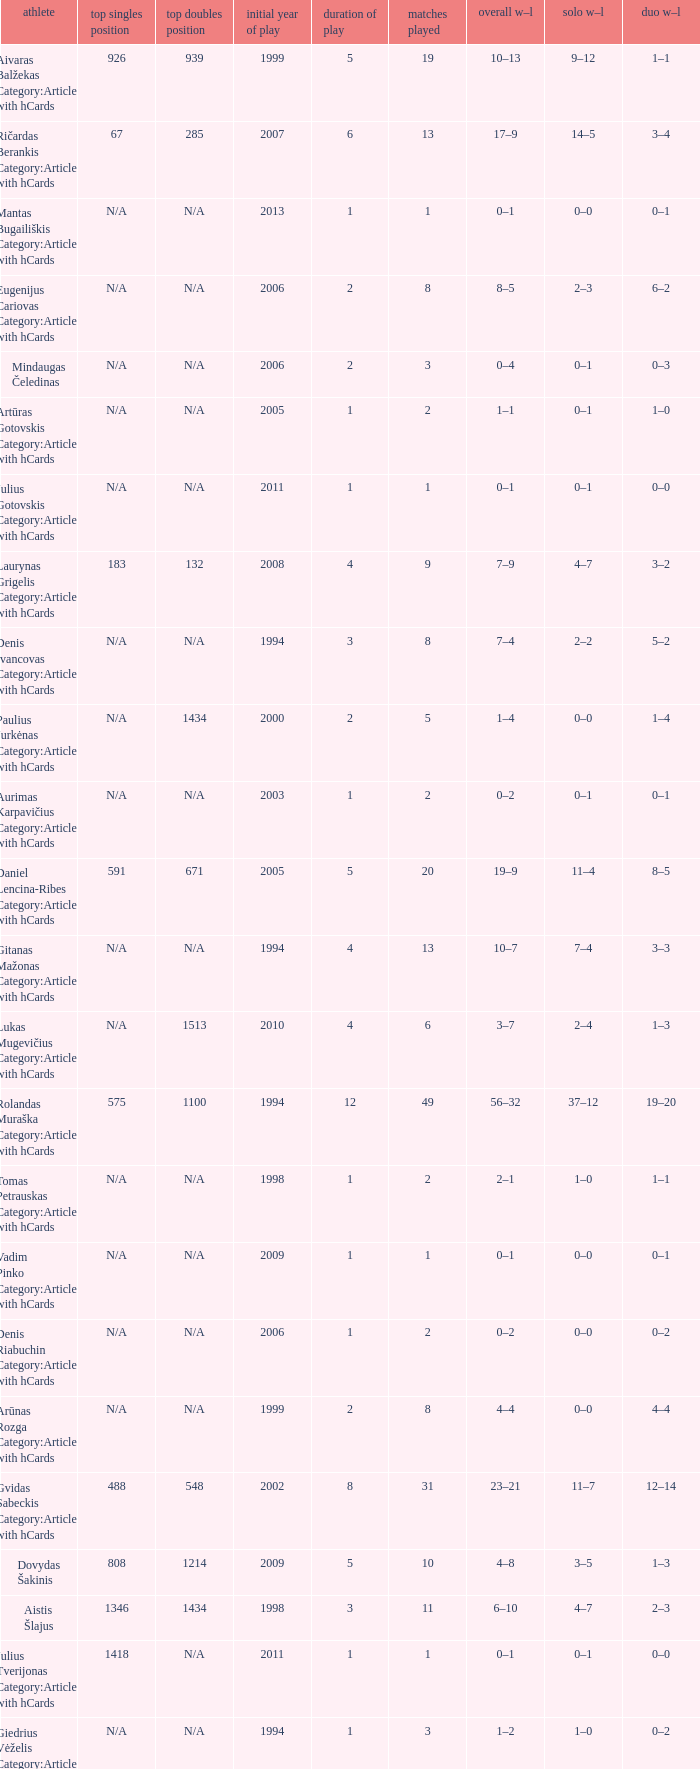Name the minimum tiesplayed for 6 years 13.0. 